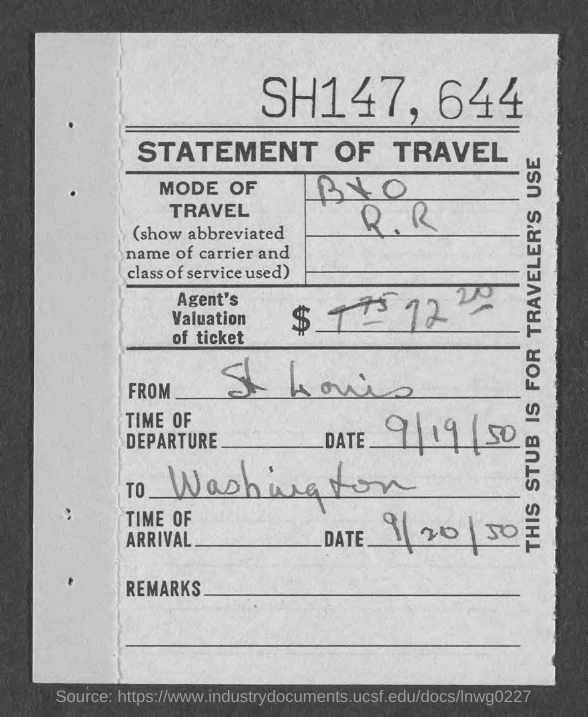What is the Title of the document?
Your response must be concise. STATEMENT OF TRAVEL. Where is it from?
Keep it short and to the point. St. Louis. What is the Date of departure?
Your answer should be very brief. 9/19/50. Where is it to?
Your response must be concise. Washington. What is the Date of arrival?
Keep it short and to the point. 9/20/50. 